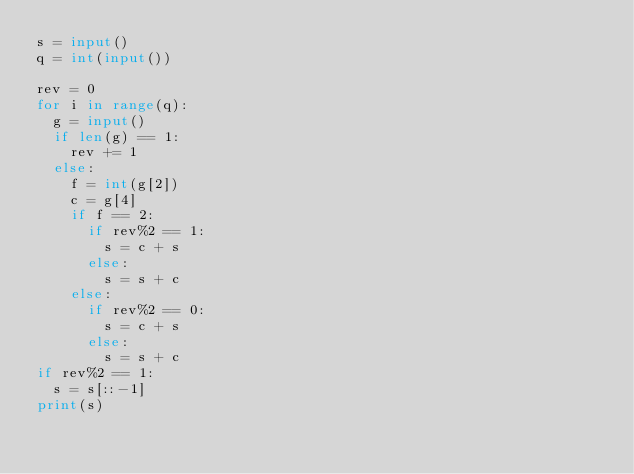Convert code to text. <code><loc_0><loc_0><loc_500><loc_500><_Python_>s = input()
q = int(input())

rev = 0
for i in range(q):
	g = input()
	if len(g) == 1:
		rev += 1
	else:
		f = int(g[2])
		c = g[4]
		if f == 2:
			if rev%2 == 1:
				s = c + s
			else:
				s = s + c
		else:
			if rev%2 == 0:
				s = c + s
			else:
				s = s + c
if rev%2 == 1:
	s = s[::-1]
print(s)</code> 